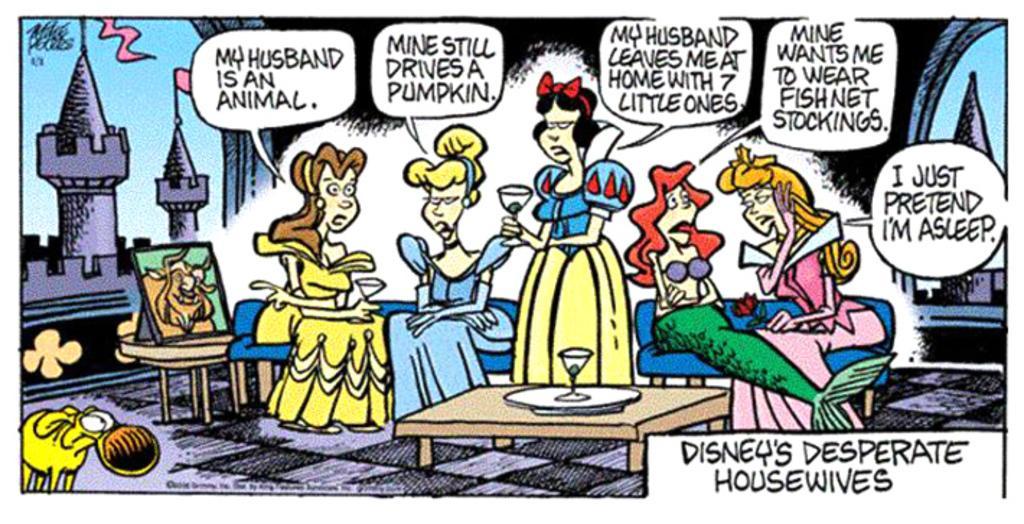Could you give a brief overview of what you see in this image? This image is an animated image in which there are persons sitting and there are texts and there is a building and there is a table and on the table there is a glass. 